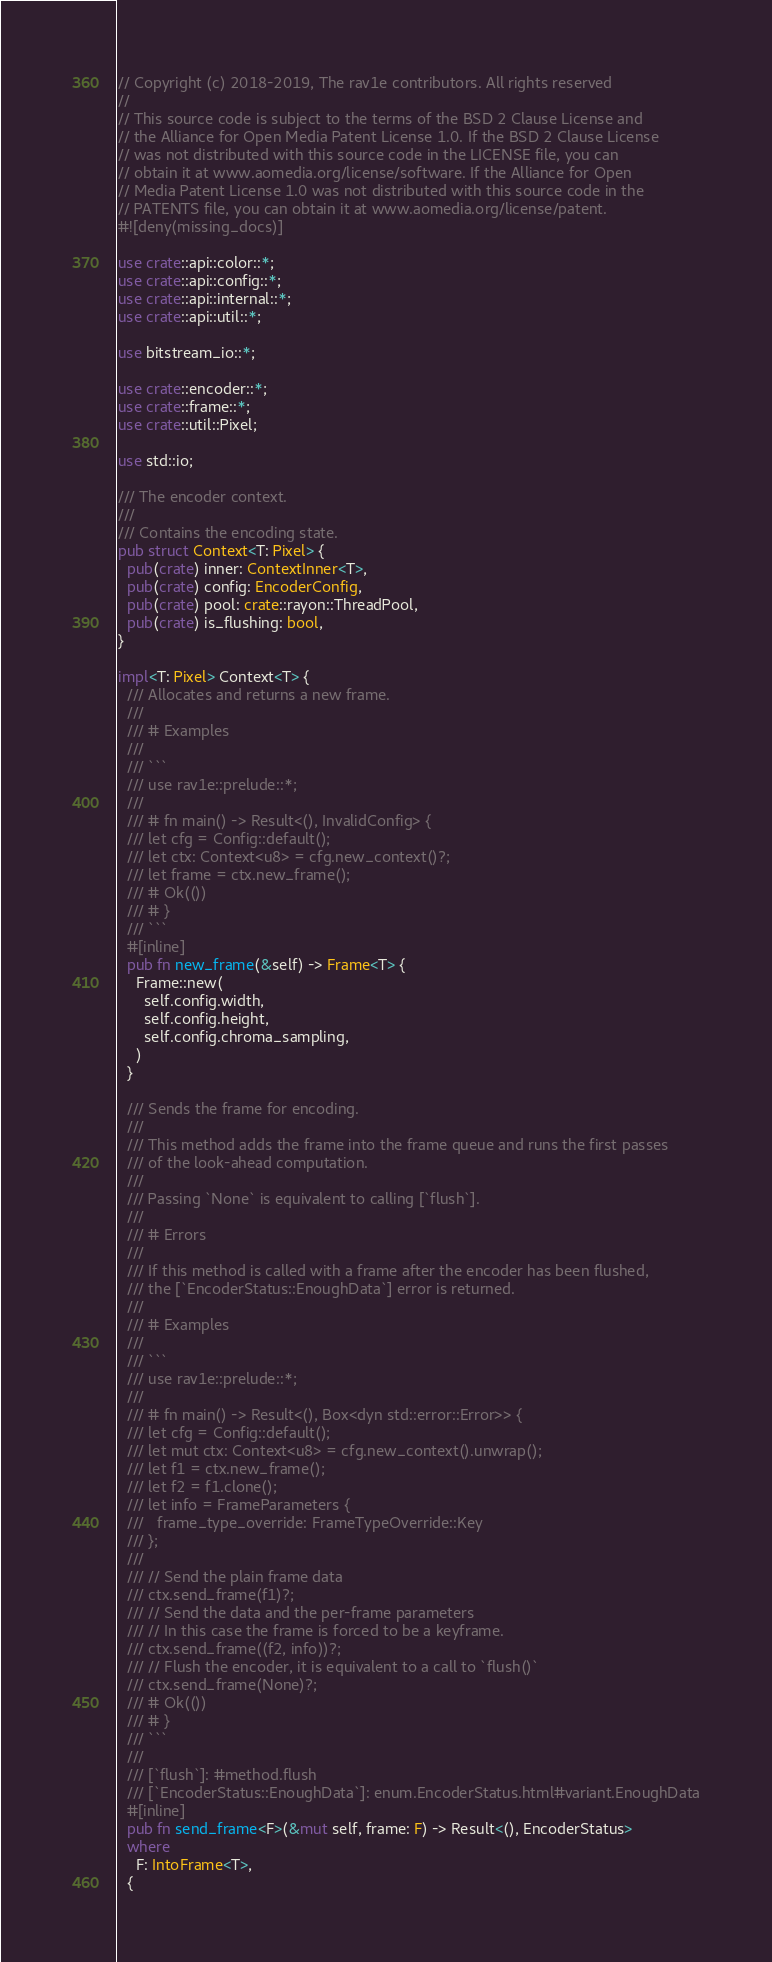<code> <loc_0><loc_0><loc_500><loc_500><_Rust_>// Copyright (c) 2018-2019, The rav1e contributors. All rights reserved
//
// This source code is subject to the terms of the BSD 2 Clause License and
// the Alliance for Open Media Patent License 1.0. If the BSD 2 Clause License
// was not distributed with this source code in the LICENSE file, you can
// obtain it at www.aomedia.org/license/software. If the Alliance for Open
// Media Patent License 1.0 was not distributed with this source code in the
// PATENTS file, you can obtain it at www.aomedia.org/license/patent.
#![deny(missing_docs)]

use crate::api::color::*;
use crate::api::config::*;
use crate::api::internal::*;
use crate::api::util::*;

use bitstream_io::*;

use crate::encoder::*;
use crate::frame::*;
use crate::util::Pixel;

use std::io;

/// The encoder context.
///
/// Contains the encoding state.
pub struct Context<T: Pixel> {
  pub(crate) inner: ContextInner<T>,
  pub(crate) config: EncoderConfig,
  pub(crate) pool: crate::rayon::ThreadPool,
  pub(crate) is_flushing: bool,
}

impl<T: Pixel> Context<T> {
  /// Allocates and returns a new frame.
  ///
  /// # Examples
  ///
  /// ```
  /// use rav1e::prelude::*;
  ///
  /// # fn main() -> Result<(), InvalidConfig> {
  /// let cfg = Config::default();
  /// let ctx: Context<u8> = cfg.new_context()?;
  /// let frame = ctx.new_frame();
  /// # Ok(())
  /// # }
  /// ```
  #[inline]
  pub fn new_frame(&self) -> Frame<T> {
    Frame::new(
      self.config.width,
      self.config.height,
      self.config.chroma_sampling,
    )
  }

  /// Sends the frame for encoding.
  ///
  /// This method adds the frame into the frame queue and runs the first passes
  /// of the look-ahead computation.
  ///
  /// Passing `None` is equivalent to calling [`flush`].
  ///
  /// # Errors
  ///
  /// If this method is called with a frame after the encoder has been flushed,
  /// the [`EncoderStatus::EnoughData`] error is returned.
  ///
  /// # Examples
  ///
  /// ```
  /// use rav1e::prelude::*;
  ///
  /// # fn main() -> Result<(), Box<dyn std::error::Error>> {
  /// let cfg = Config::default();
  /// let mut ctx: Context<u8> = cfg.new_context().unwrap();
  /// let f1 = ctx.new_frame();
  /// let f2 = f1.clone();
  /// let info = FrameParameters {
  ///   frame_type_override: FrameTypeOverride::Key
  /// };
  ///
  /// // Send the plain frame data
  /// ctx.send_frame(f1)?;
  /// // Send the data and the per-frame parameters
  /// // In this case the frame is forced to be a keyframe.
  /// ctx.send_frame((f2, info))?;
  /// // Flush the encoder, it is equivalent to a call to `flush()`
  /// ctx.send_frame(None)?;
  /// # Ok(())
  /// # }
  /// ```
  ///
  /// [`flush`]: #method.flush
  /// [`EncoderStatus::EnoughData`]: enum.EncoderStatus.html#variant.EnoughData
  #[inline]
  pub fn send_frame<F>(&mut self, frame: F) -> Result<(), EncoderStatus>
  where
    F: IntoFrame<T>,
  {</code> 